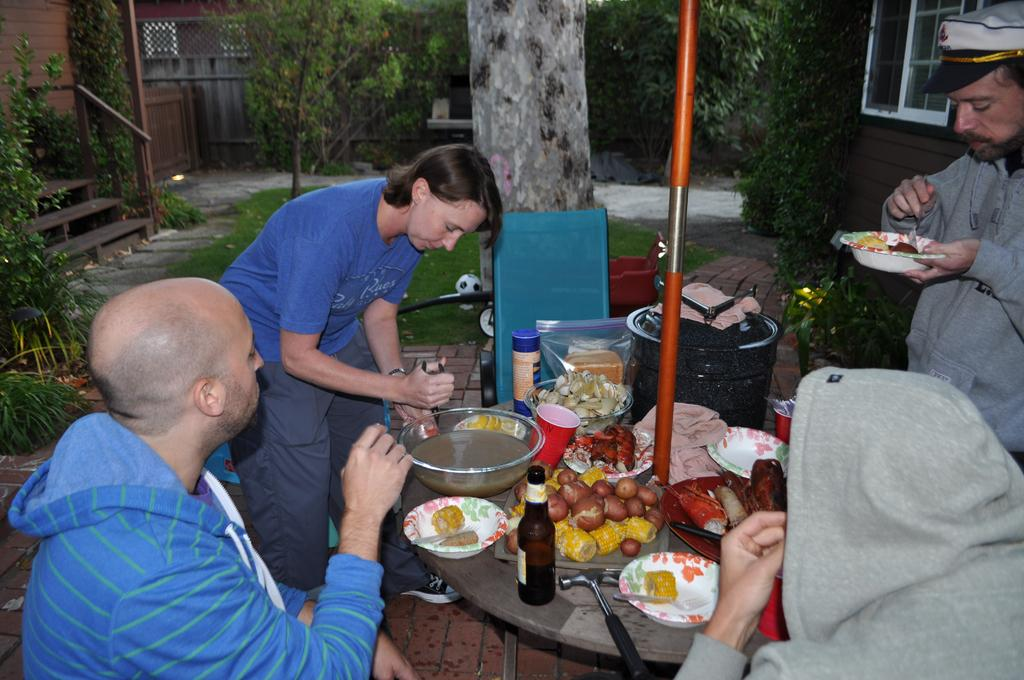How many people are in the image? There are people in the image, but the exact number is not specified. What are the people doing in the image? Some people are standing, while others are sitting on chairs. What can be seen on the table in the image? There is a plate in the image. What is on the plate? The plate contains food items. What type of cable can be seen connecting the people in the image? There is no cable present in the image. 